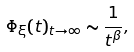Convert formula to latex. <formula><loc_0><loc_0><loc_500><loc_500>\Phi _ { \xi } ( t ) _ { t \to \infty } \sim \frac { 1 } { t ^ { \beta } } ,</formula> 